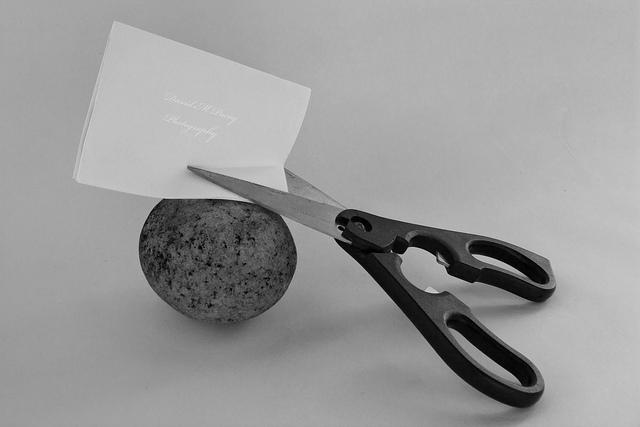What color are the scissor's handle?
Quick response, please. Black. What did the person just cut up?
Write a very short answer. Paper. Is there a ball on the table?
Concise answer only. Yes. What color is the scissors?
Write a very short answer. Black. What are the scissors cutting?
Write a very short answer. Paper. Can this contraption throw balls on its own?
Keep it brief. No. What square colorful image is above the scissors?
Short answer required. Paper. How many objects are in this photo?
Give a very brief answer. 3. 